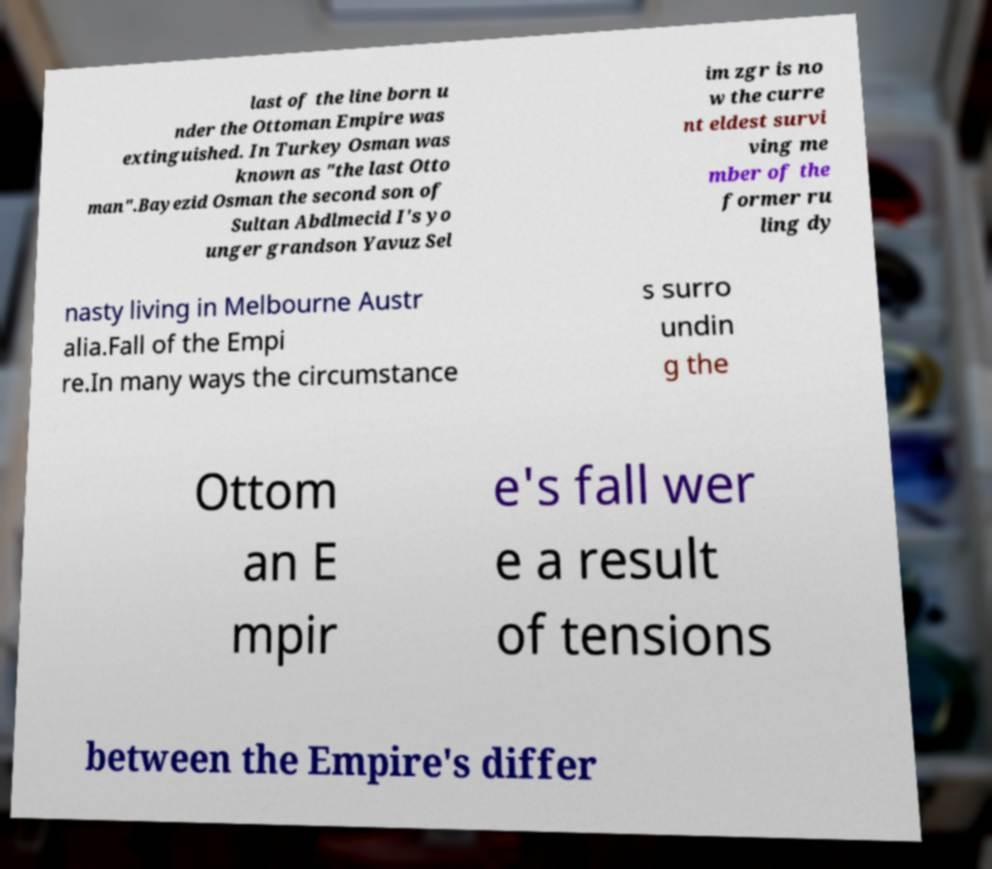Can you read and provide the text displayed in the image?This photo seems to have some interesting text. Can you extract and type it out for me? last of the line born u nder the Ottoman Empire was extinguished. In Turkey Osman was known as "the last Otto man".Bayezid Osman the second son of Sultan Abdlmecid I's yo unger grandson Yavuz Sel im zgr is no w the curre nt eldest survi ving me mber of the former ru ling dy nasty living in Melbourne Austr alia.Fall of the Empi re.In many ways the circumstance s surro undin g the Ottom an E mpir e's fall wer e a result of tensions between the Empire's differ 